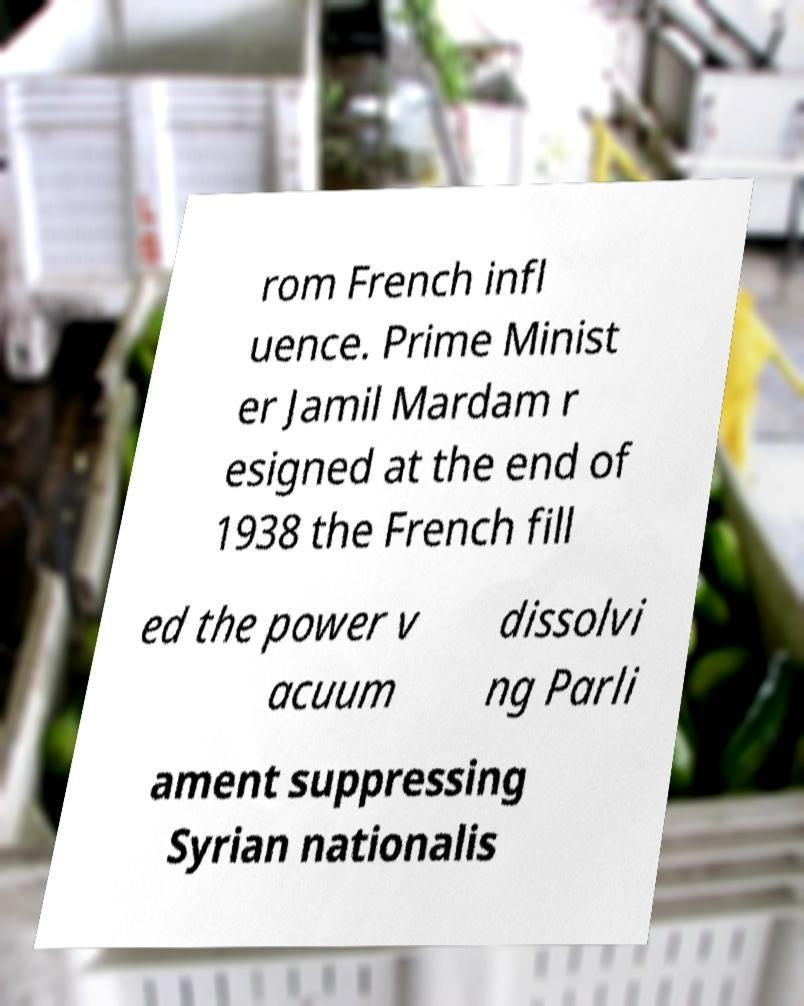There's text embedded in this image that I need extracted. Can you transcribe it verbatim? rom French infl uence. Prime Minist er Jamil Mardam r esigned at the end of 1938 the French fill ed the power v acuum dissolvi ng Parli ament suppressing Syrian nationalis 